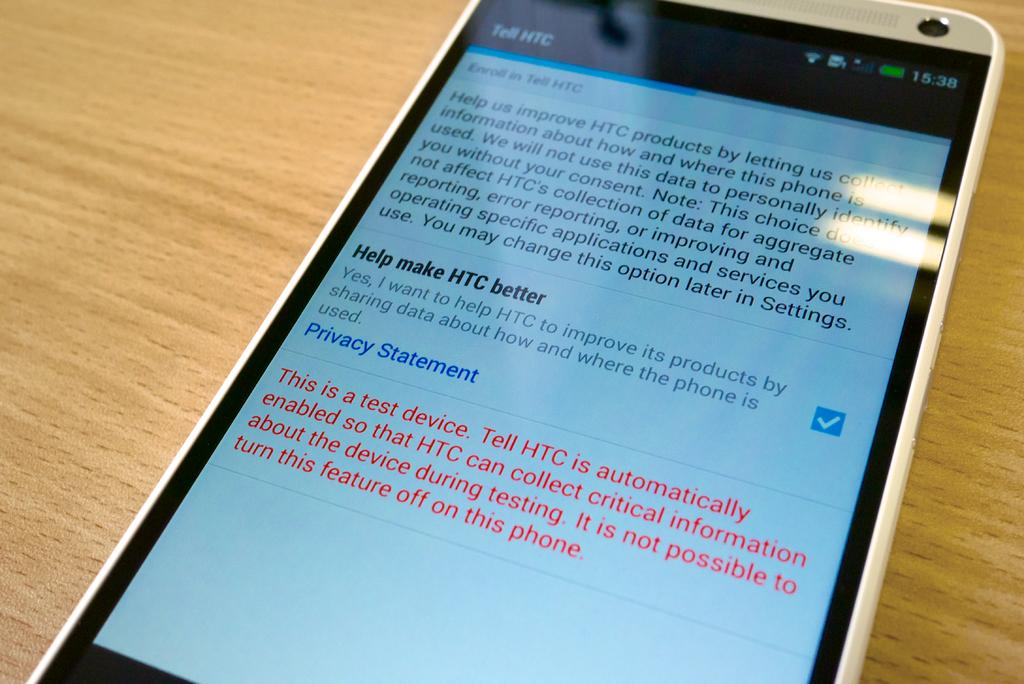Provide a one-sentence caption for the provided image. A HTC cellphone showing the screen about "Tell HTC". 